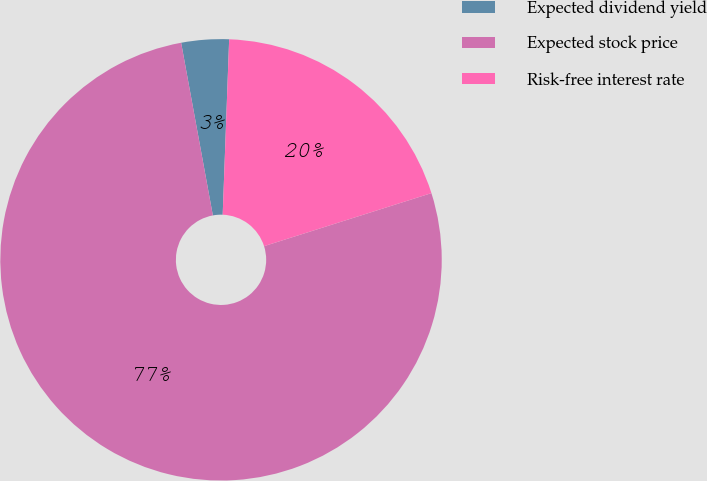Convert chart. <chart><loc_0><loc_0><loc_500><loc_500><pie_chart><fcel>Expected dividend yield<fcel>Expected stock price<fcel>Risk-free interest rate<nl><fcel>3.48%<fcel>77.0%<fcel>19.53%<nl></chart> 